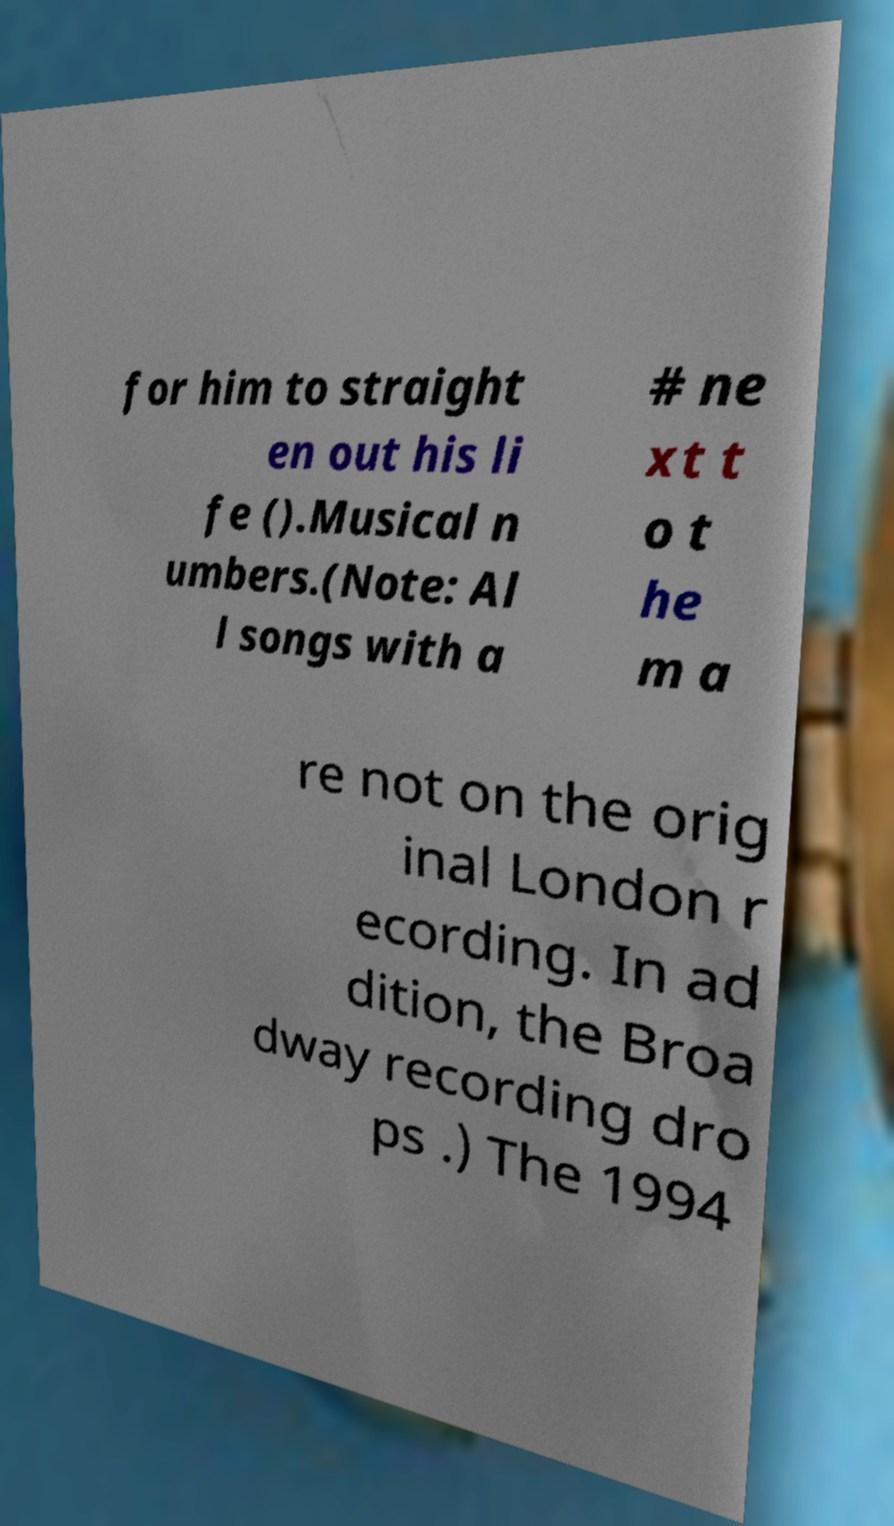Please read and relay the text visible in this image. What does it say? for him to straight en out his li fe ().Musical n umbers.(Note: Al l songs with a # ne xt t o t he m a re not on the orig inal London r ecording. In ad dition, the Broa dway recording dro ps .) The 1994 